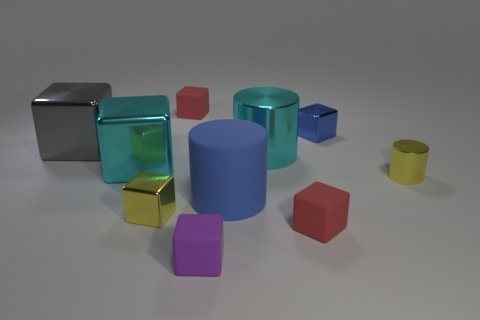Subtract 2 cylinders. How many cylinders are left? 1 Subtract all big cylinders. How many cylinders are left? 1 Add 9 purple blocks. How many purple blocks are left? 10 Add 4 blue cylinders. How many blue cylinders exist? 5 Subtract all cyan cylinders. How many cylinders are left? 2 Subtract 0 brown cylinders. How many objects are left? 10 Subtract all blocks. How many objects are left? 3 Subtract all green blocks. Subtract all red balls. How many blocks are left? 7 Subtract all purple cubes. How many cyan cylinders are left? 1 Subtract all cyan rubber things. Subtract all blue metal cubes. How many objects are left? 9 